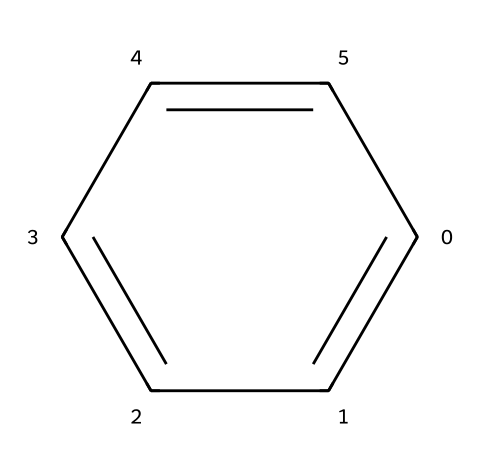How many carbon atoms are in benzene? The SMILES representation 'c1ccccc1' indicates that there are six carbon atoms in the molecule. Each 'c' represents a carbon atom in the aromatic ring.
Answer: six What type of hybridization is present in the carbon atoms of benzene? The carbon atoms in benzene undergo sp² hybridization, as each carbon is bonded to two adjacent carbons and one hydrogen atom, forming a planar structure with 120-degree bond angles.
Answer: sp² How many hydrogen atoms are bonded to benzene? Each of the six carbon atoms in benzene is bonded to one hydrogen atom, resulting in a total of six hydrogen atoms in the structure.
Answer: six What is the bond order of the carbon-carbon bonds in benzene? In benzene, the carbon-carbon bond order is 1.5 due to resonance, where the bonds are delocalized across the six carbon atoms.
Answer: 1.5 Is benzene a saturated or unsaturated compound? Benzene is an unsaturated compound because it contains alternating double bonds or equivalent resonance structures, leading to fewer hydrogen atoms compared to a saturated compound with the same number of carbons.
Answer: unsaturated What is the angle between carbon-carbon bonds in benzene? The angle between the carbon-carbon bonds in benzene is approximately 120 degrees, characteristic of sp² hybridization in a planar structure.
Answer: 120 degrees What is the defining feature of aromatic compounds that benzene exhibits? Benzene exhibits resonance stabilization, allowing for the delocalization of π electrons over the carbon atoms, which is a key characteristic of aromatic compounds.
Answer: resonance stabilization 